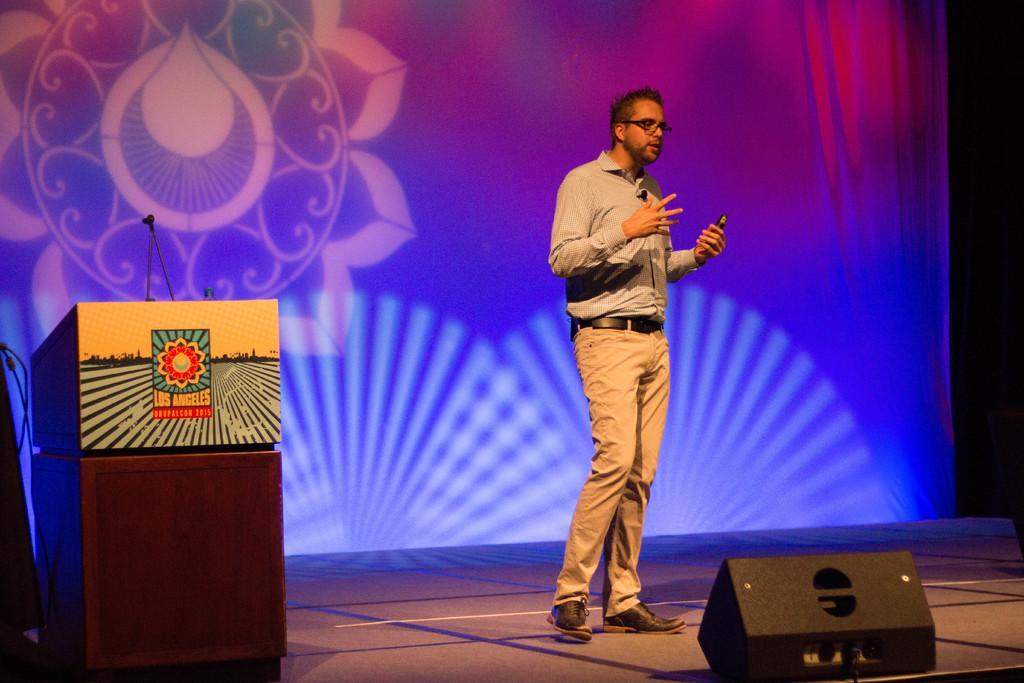In one or two sentences, can you explain what this image depicts? In this image a person is standing on the stage. He is wearing spectacles. Left side there is a podium having a mike on it. Bottom of the image there is an object on the stage. Background there is a screen having an image displayed on it. 